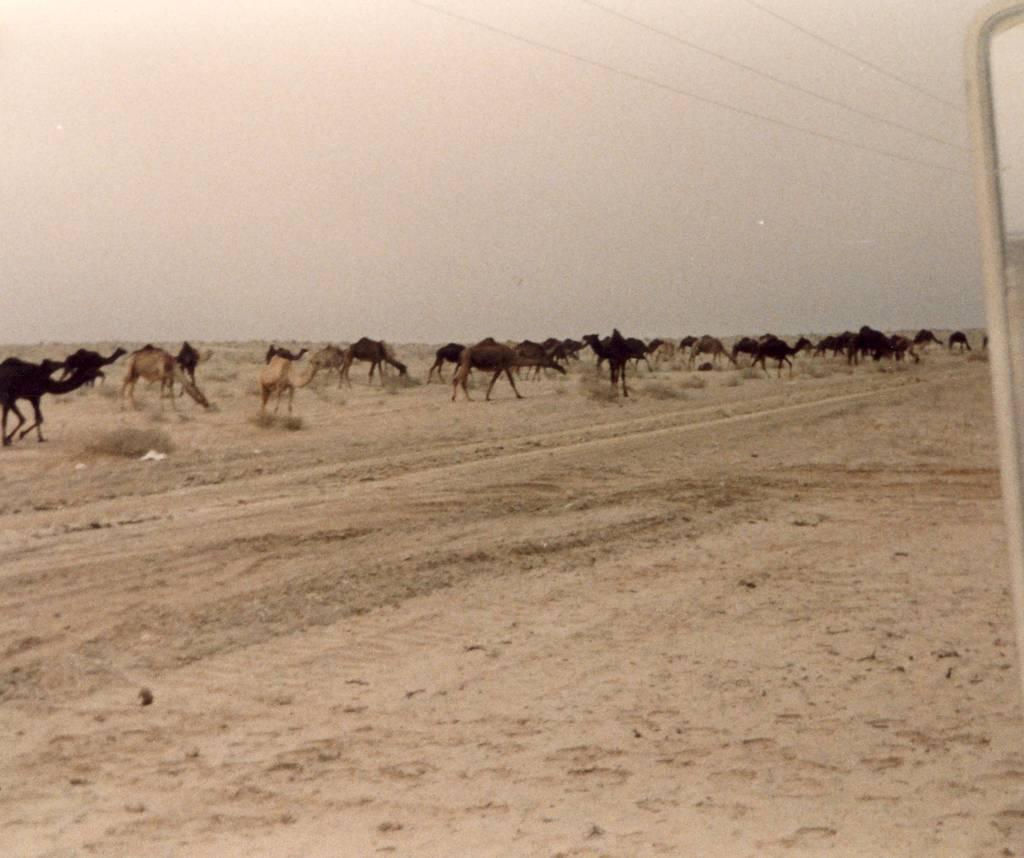Could you give a brief overview of what you see in this image? In this picture we can see a group of camels on sand, plants, pole, wires and in the background we can see the sky. 